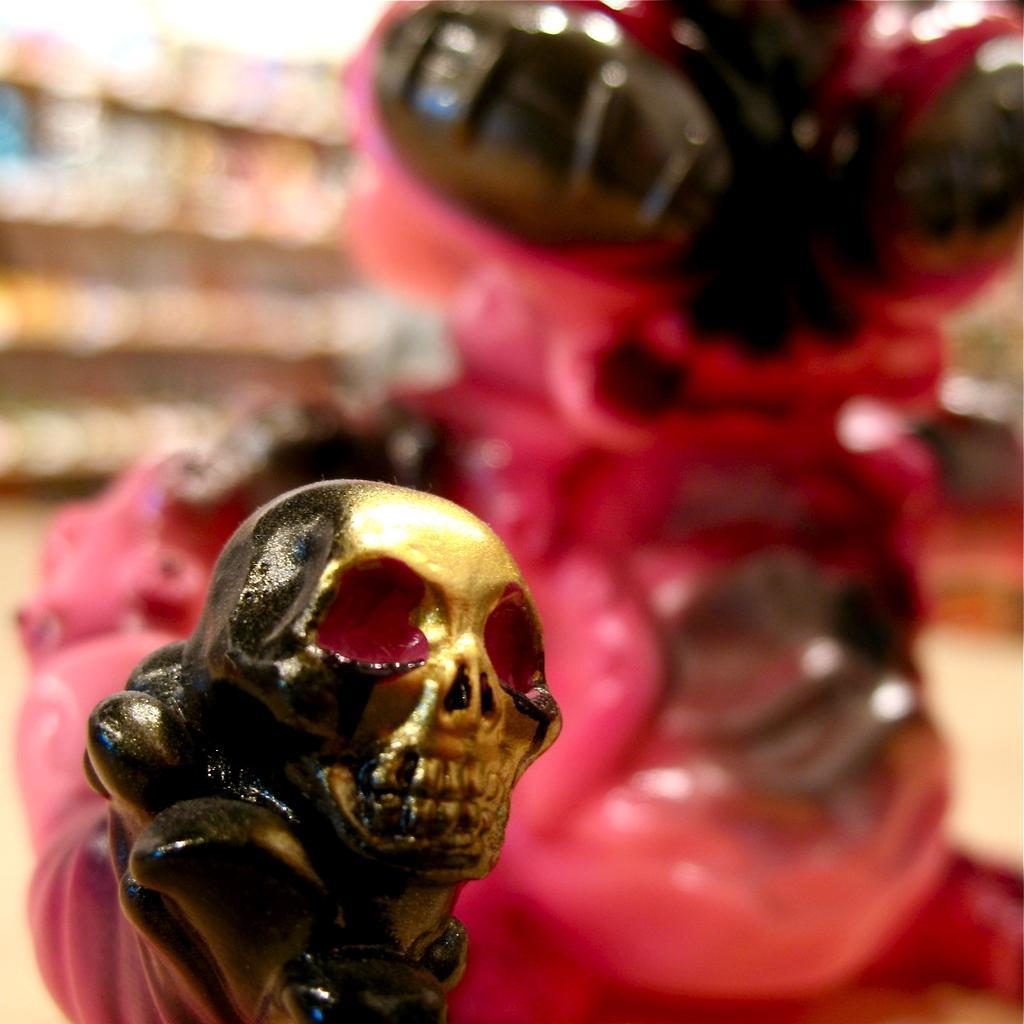In one or two sentences, can you explain what this image depicts? As we can see in the image in the front there are toys and the background is blurred. 